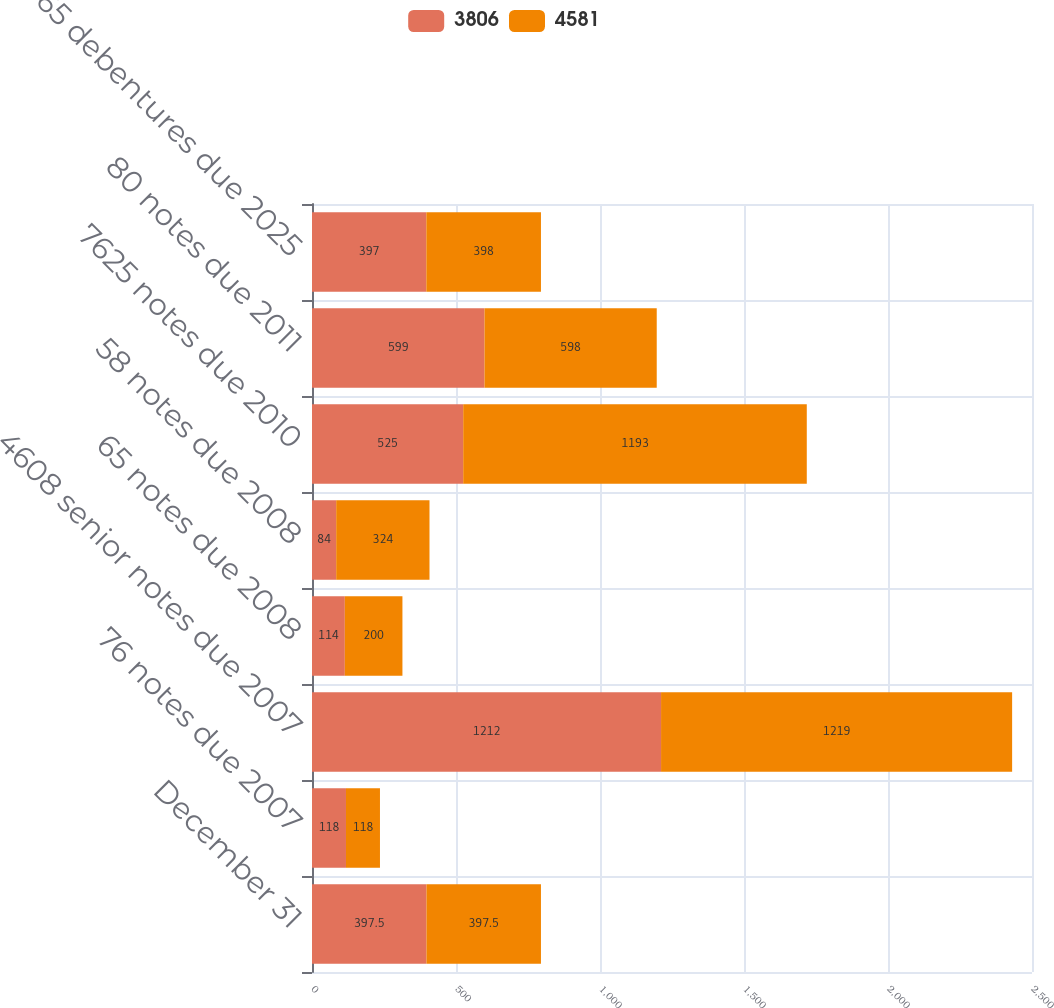Convert chart to OTSL. <chart><loc_0><loc_0><loc_500><loc_500><stacked_bar_chart><ecel><fcel>December 31<fcel>76 notes due 2007<fcel>4608 senior notes due 2007<fcel>65 notes due 2008<fcel>58 notes due 2008<fcel>7625 notes due 2010<fcel>80 notes due 2011<fcel>65 debentures due 2025<nl><fcel>3806<fcel>397.5<fcel>118<fcel>1212<fcel>114<fcel>84<fcel>525<fcel>599<fcel>397<nl><fcel>4581<fcel>397.5<fcel>118<fcel>1219<fcel>200<fcel>324<fcel>1193<fcel>598<fcel>398<nl></chart> 